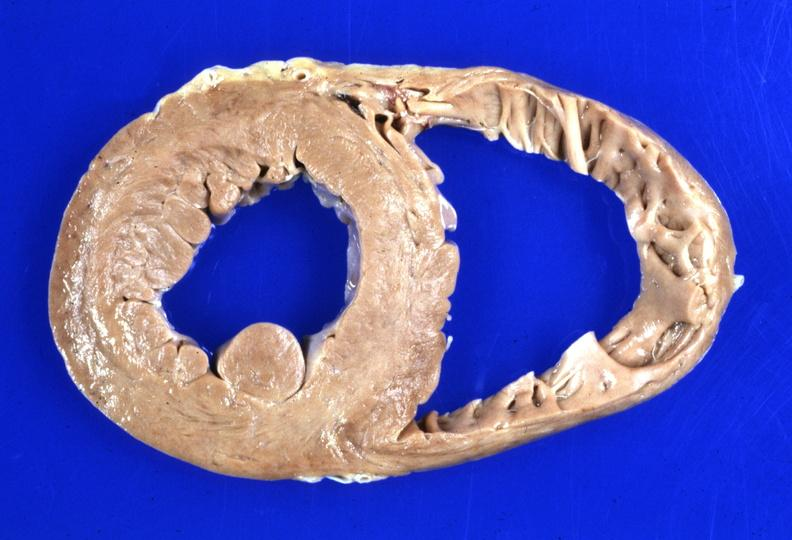does this image show heart dilation?
Answer the question using a single word or phrase. Yes 